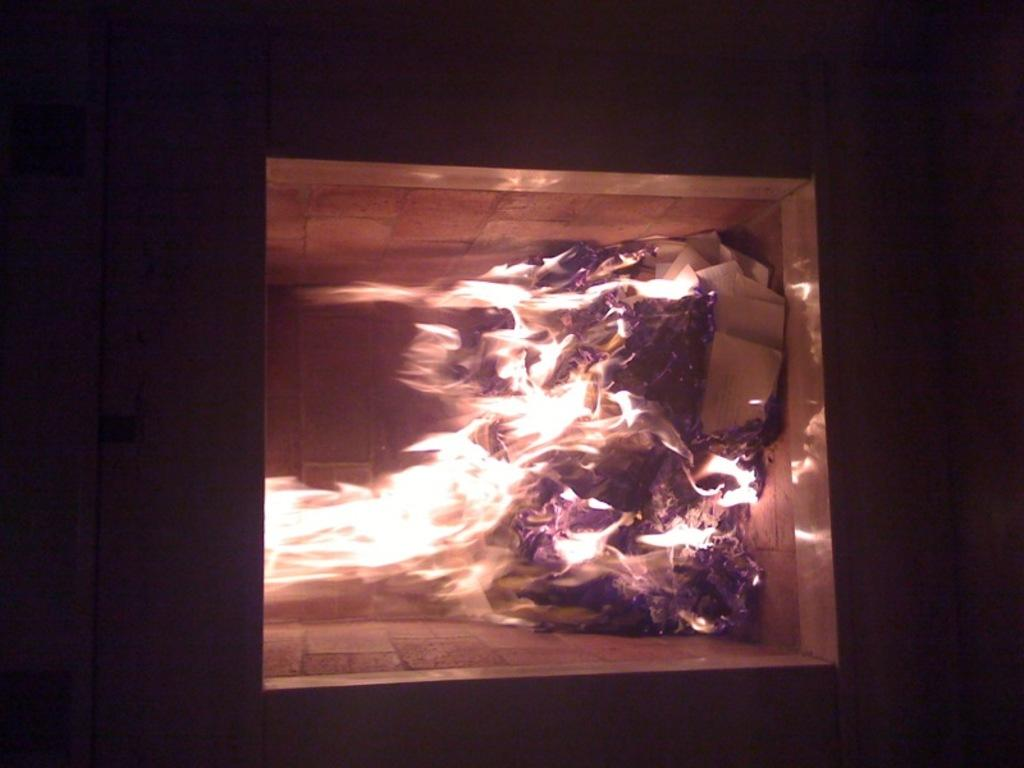What is the main element in the image? There is fire in the image. What else can be seen in the middle of the image? There is a wall in the image. How would you describe the overall setting of the image? The background of the image is dark. What type of sound can be heard coming from the stream in the image? There is no stream present in the image, so it's not possible to determine what, if any, sounds might be heard. 